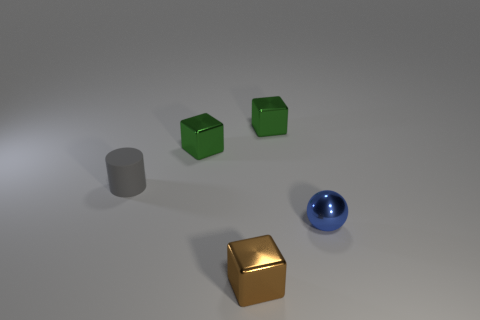Add 1 tiny brown blocks. How many objects exist? 6 Subtract all blocks. How many objects are left? 2 Subtract all small green metal blocks. Subtract all brown shiny blocks. How many objects are left? 2 Add 1 shiny cubes. How many shiny cubes are left? 4 Add 4 small gray shiny things. How many small gray shiny things exist? 4 Subtract 0 blue cubes. How many objects are left? 5 